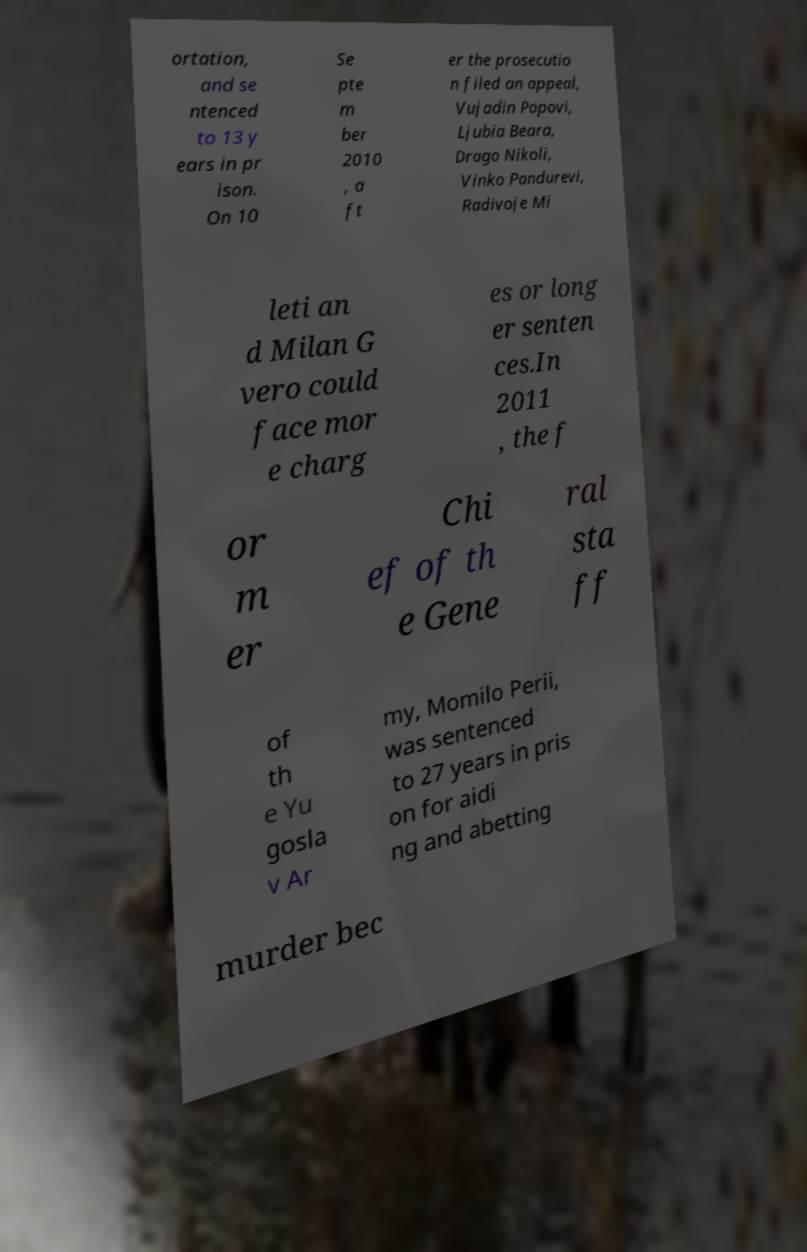Can you accurately transcribe the text from the provided image for me? ortation, and se ntenced to 13 y ears in pr ison. On 10 Se pte m ber 2010 , a ft er the prosecutio n filed an appeal, Vujadin Popovi, Ljubia Beara, Drago Nikoli, Vinko Pandurevi, Radivoje Mi leti an d Milan G vero could face mor e charg es or long er senten ces.In 2011 , the f or m er Chi ef of th e Gene ral sta ff of th e Yu gosla v Ar my, Momilo Perii, was sentenced to 27 years in pris on for aidi ng and abetting murder bec 